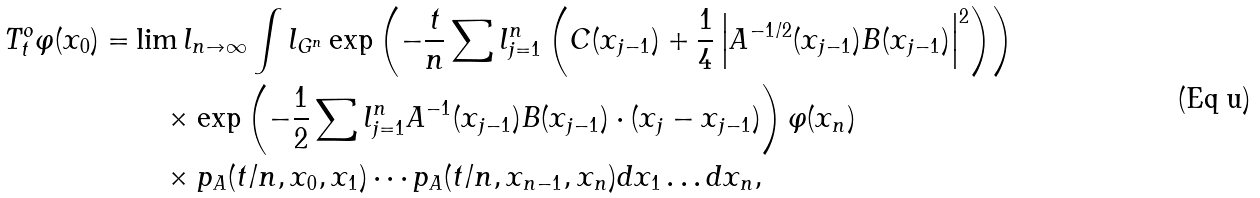Convert formula to latex. <formula><loc_0><loc_0><loc_500><loc_500>T ^ { o } _ { t } \varphi ( x _ { 0 } ) = & \lim l _ { n \to \infty } \int l _ { G ^ { n } } \exp \left ( - \frac { t } { n } \sum l _ { j = 1 } ^ { n } \left ( C ( x _ { j - 1 } ) + \frac { 1 } { 4 } \left | A ^ { - 1 / 2 } ( x _ { j - 1 } ) B ( x _ { j - 1 } ) \right | ^ { 2 } \right ) \right ) \\ & \quad \times \exp \left ( - \frac { 1 } { 2 } \sum l _ { j = 1 } ^ { n } A ^ { - 1 } ( x _ { j - 1 } ) B ( x _ { j - 1 } ) \cdot ( x _ { j } - x _ { j - 1 } ) \right ) \varphi ( x _ { n } ) \\ & \quad \times p _ { A } ( t / n , x _ { 0 } , x _ { 1 } ) \cdots p _ { A } ( t / n , x _ { n - 1 } , x _ { n } ) d x _ { 1 } \dots d x _ { n } ,</formula> 